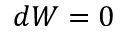<formula> <loc_0><loc_0><loc_500><loc_500>d W = 0</formula> 